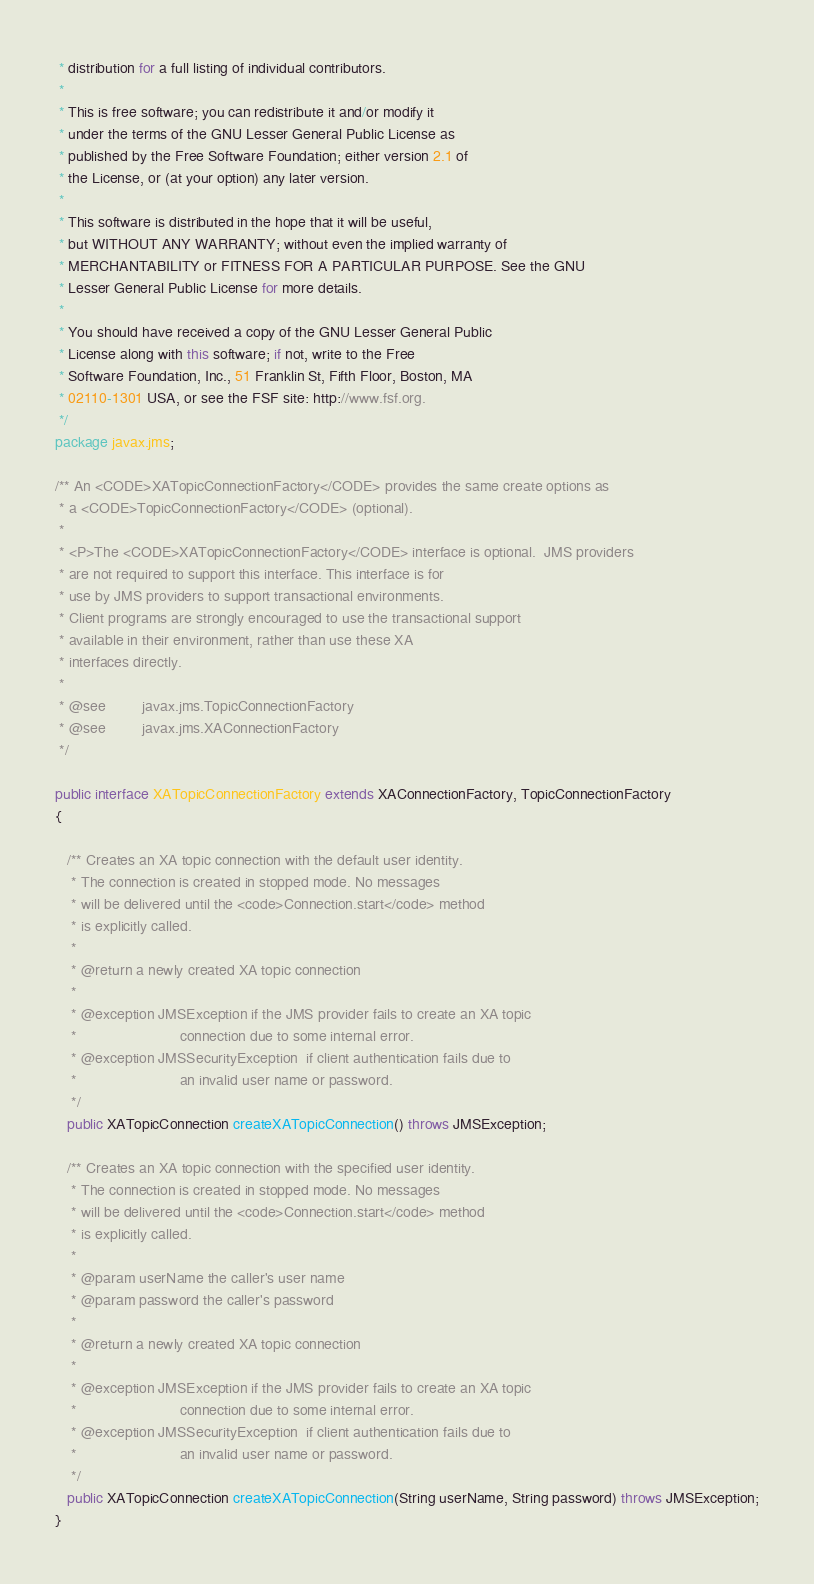<code> <loc_0><loc_0><loc_500><loc_500><_Java_> * distribution for a full listing of individual contributors.
 *
 * This is free software; you can redistribute it and/or modify it
 * under the terms of the GNU Lesser General Public License as
 * published by the Free Software Foundation; either version 2.1 of
 * the License, or (at your option) any later version.
 *
 * This software is distributed in the hope that it will be useful,
 * but WITHOUT ANY WARRANTY; without even the implied warranty of
 * MERCHANTABILITY or FITNESS FOR A PARTICULAR PURPOSE. See the GNU
 * Lesser General Public License for more details.
 *
 * You should have received a copy of the GNU Lesser General Public
 * License along with this software; if not, write to the Free
 * Software Foundation, Inc., 51 Franklin St, Fifth Floor, Boston, MA
 * 02110-1301 USA, or see the FSF site: http://www.fsf.org.
 */
package javax.jms;

/** An <CODE>XATopicConnectionFactory</CODE> provides the same create options as 
 * a <CODE>TopicConnectionFactory</CODE> (optional).
 *
 * <P>The <CODE>XATopicConnectionFactory</CODE> interface is optional.  JMS providers 
 * are not required to support this interface. This interface is for 
 * use by JMS providers to support transactional environments. 
 * Client programs are strongly encouraged to use the transactional support
 * available in their environment, rather than use these XA
 * interfaces directly. 
 *
 * @see         javax.jms.TopicConnectionFactory
 * @see         javax.jms.XAConnectionFactory
 */

public interface XATopicConnectionFactory extends XAConnectionFactory, TopicConnectionFactory
{

   /** Creates an XA topic connection with the default user identity.
    * The connection is created in stopped mode. No messages 
    * will be delivered until the <code>Connection.start</code> method
    * is explicitly called.
    *
    * @return a newly created XA topic connection
    *
    * @exception JMSException if the JMS provider fails to create an XA topic 
    *                         connection due to some internal error.
    * @exception JMSSecurityException  if client authentication fails due to 
    *                         an invalid user name or password.
    */
   public XATopicConnection createXATopicConnection() throws JMSException;

   /** Creates an XA topic connection with the specified user identity.
    * The connection is created in stopped mode. No messages 
    * will be delivered until the <code>Connection.start</code> method
    * is explicitly called.
    *  
    * @param userName the caller's user name
    * @param password the caller's password
    *  
    * @return a newly created XA topic connection
    *
    * @exception JMSException if the JMS provider fails to create an XA topic 
    *                         connection due to some internal error.
    * @exception JMSSecurityException  if client authentication fails due to 
    *                         an invalid user name or password.
    */
   public XATopicConnection createXATopicConnection(String userName, String password) throws JMSException;
}
</code> 